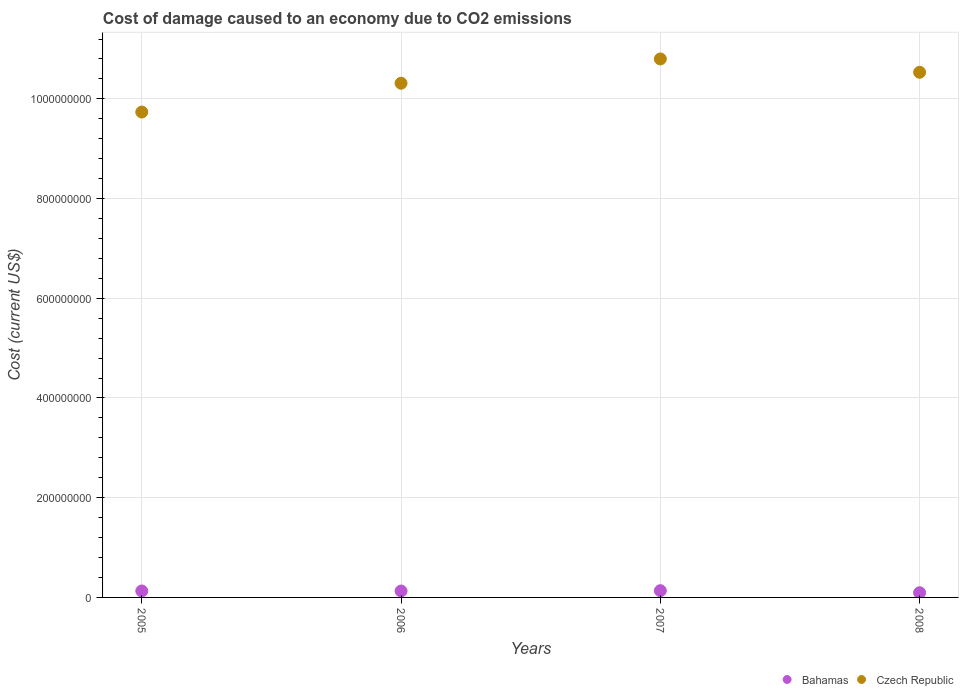How many different coloured dotlines are there?
Make the answer very short. 2. Is the number of dotlines equal to the number of legend labels?
Provide a short and direct response. Yes. What is the cost of damage caused due to CO2 emissisons in Bahamas in 2008?
Your answer should be very brief. 9.43e+06. Across all years, what is the maximum cost of damage caused due to CO2 emissisons in Czech Republic?
Keep it short and to the point. 1.08e+09. Across all years, what is the minimum cost of damage caused due to CO2 emissisons in Czech Republic?
Your answer should be very brief. 9.74e+08. In which year was the cost of damage caused due to CO2 emissisons in Bahamas minimum?
Your answer should be compact. 2008. What is the total cost of damage caused due to CO2 emissisons in Czech Republic in the graph?
Provide a short and direct response. 4.14e+09. What is the difference between the cost of damage caused due to CO2 emissisons in Bahamas in 2005 and that in 2006?
Your answer should be very brief. 1.12e+05. What is the difference between the cost of damage caused due to CO2 emissisons in Bahamas in 2006 and the cost of damage caused due to CO2 emissisons in Czech Republic in 2007?
Offer a terse response. -1.07e+09. What is the average cost of damage caused due to CO2 emissisons in Czech Republic per year?
Make the answer very short. 1.03e+09. In the year 2007, what is the difference between the cost of damage caused due to CO2 emissisons in Czech Republic and cost of damage caused due to CO2 emissisons in Bahamas?
Keep it short and to the point. 1.07e+09. In how many years, is the cost of damage caused due to CO2 emissisons in Bahamas greater than 360000000 US$?
Your answer should be compact. 0. What is the ratio of the cost of damage caused due to CO2 emissisons in Bahamas in 2006 to that in 2008?
Offer a very short reply. 1.36. What is the difference between the highest and the second highest cost of damage caused due to CO2 emissisons in Bahamas?
Keep it short and to the point. 5.94e+05. What is the difference between the highest and the lowest cost of damage caused due to CO2 emissisons in Bahamas?
Offer a very short reply. 4.12e+06. In how many years, is the cost of damage caused due to CO2 emissisons in Bahamas greater than the average cost of damage caused due to CO2 emissisons in Bahamas taken over all years?
Your response must be concise. 3. Does the cost of damage caused due to CO2 emissisons in Czech Republic monotonically increase over the years?
Ensure brevity in your answer.  No. Is the cost of damage caused due to CO2 emissisons in Bahamas strictly greater than the cost of damage caused due to CO2 emissisons in Czech Republic over the years?
Provide a succinct answer. No. How many dotlines are there?
Give a very brief answer. 2. How many years are there in the graph?
Your response must be concise. 4. Does the graph contain any zero values?
Offer a terse response. No. Does the graph contain grids?
Make the answer very short. Yes. How are the legend labels stacked?
Give a very brief answer. Horizontal. What is the title of the graph?
Your answer should be very brief. Cost of damage caused to an economy due to CO2 emissions. Does "Philippines" appear as one of the legend labels in the graph?
Offer a very short reply. No. What is the label or title of the Y-axis?
Your answer should be compact. Cost (current US$). What is the Cost (current US$) of Bahamas in 2005?
Make the answer very short. 1.30e+07. What is the Cost (current US$) of Czech Republic in 2005?
Provide a succinct answer. 9.74e+08. What is the Cost (current US$) in Bahamas in 2006?
Ensure brevity in your answer.  1.28e+07. What is the Cost (current US$) of Czech Republic in 2006?
Offer a very short reply. 1.03e+09. What is the Cost (current US$) of Bahamas in 2007?
Keep it short and to the point. 1.36e+07. What is the Cost (current US$) of Czech Republic in 2007?
Give a very brief answer. 1.08e+09. What is the Cost (current US$) in Bahamas in 2008?
Your response must be concise. 9.43e+06. What is the Cost (current US$) in Czech Republic in 2008?
Offer a very short reply. 1.05e+09. Across all years, what is the maximum Cost (current US$) in Bahamas?
Offer a terse response. 1.36e+07. Across all years, what is the maximum Cost (current US$) in Czech Republic?
Ensure brevity in your answer.  1.08e+09. Across all years, what is the minimum Cost (current US$) of Bahamas?
Your answer should be very brief. 9.43e+06. Across all years, what is the minimum Cost (current US$) in Czech Republic?
Offer a very short reply. 9.74e+08. What is the total Cost (current US$) of Bahamas in the graph?
Keep it short and to the point. 4.88e+07. What is the total Cost (current US$) of Czech Republic in the graph?
Offer a very short reply. 4.14e+09. What is the difference between the Cost (current US$) of Bahamas in 2005 and that in 2006?
Ensure brevity in your answer.  1.12e+05. What is the difference between the Cost (current US$) in Czech Republic in 2005 and that in 2006?
Provide a short and direct response. -5.78e+07. What is the difference between the Cost (current US$) in Bahamas in 2005 and that in 2007?
Keep it short and to the point. -5.94e+05. What is the difference between the Cost (current US$) of Czech Republic in 2005 and that in 2007?
Your answer should be very brief. -1.07e+08. What is the difference between the Cost (current US$) in Bahamas in 2005 and that in 2008?
Your answer should be very brief. 3.53e+06. What is the difference between the Cost (current US$) in Czech Republic in 2005 and that in 2008?
Your answer should be very brief. -7.98e+07. What is the difference between the Cost (current US$) in Bahamas in 2006 and that in 2007?
Provide a succinct answer. -7.05e+05. What is the difference between the Cost (current US$) of Czech Republic in 2006 and that in 2007?
Keep it short and to the point. -4.87e+07. What is the difference between the Cost (current US$) of Bahamas in 2006 and that in 2008?
Make the answer very short. 3.42e+06. What is the difference between the Cost (current US$) in Czech Republic in 2006 and that in 2008?
Provide a short and direct response. -2.20e+07. What is the difference between the Cost (current US$) in Bahamas in 2007 and that in 2008?
Offer a very short reply. 4.12e+06. What is the difference between the Cost (current US$) in Czech Republic in 2007 and that in 2008?
Keep it short and to the point. 2.68e+07. What is the difference between the Cost (current US$) in Bahamas in 2005 and the Cost (current US$) in Czech Republic in 2006?
Ensure brevity in your answer.  -1.02e+09. What is the difference between the Cost (current US$) in Bahamas in 2005 and the Cost (current US$) in Czech Republic in 2007?
Keep it short and to the point. -1.07e+09. What is the difference between the Cost (current US$) in Bahamas in 2005 and the Cost (current US$) in Czech Republic in 2008?
Keep it short and to the point. -1.04e+09. What is the difference between the Cost (current US$) of Bahamas in 2006 and the Cost (current US$) of Czech Republic in 2007?
Keep it short and to the point. -1.07e+09. What is the difference between the Cost (current US$) of Bahamas in 2006 and the Cost (current US$) of Czech Republic in 2008?
Provide a succinct answer. -1.04e+09. What is the difference between the Cost (current US$) in Bahamas in 2007 and the Cost (current US$) in Czech Republic in 2008?
Make the answer very short. -1.04e+09. What is the average Cost (current US$) of Bahamas per year?
Give a very brief answer. 1.22e+07. What is the average Cost (current US$) of Czech Republic per year?
Keep it short and to the point. 1.03e+09. In the year 2005, what is the difference between the Cost (current US$) in Bahamas and Cost (current US$) in Czech Republic?
Give a very brief answer. -9.61e+08. In the year 2006, what is the difference between the Cost (current US$) in Bahamas and Cost (current US$) in Czech Republic?
Your answer should be very brief. -1.02e+09. In the year 2007, what is the difference between the Cost (current US$) of Bahamas and Cost (current US$) of Czech Republic?
Provide a succinct answer. -1.07e+09. In the year 2008, what is the difference between the Cost (current US$) of Bahamas and Cost (current US$) of Czech Republic?
Your answer should be compact. -1.04e+09. What is the ratio of the Cost (current US$) of Bahamas in 2005 to that in 2006?
Make the answer very short. 1.01. What is the ratio of the Cost (current US$) of Czech Republic in 2005 to that in 2006?
Your answer should be very brief. 0.94. What is the ratio of the Cost (current US$) in Bahamas in 2005 to that in 2007?
Your answer should be very brief. 0.96. What is the ratio of the Cost (current US$) of Czech Republic in 2005 to that in 2007?
Provide a short and direct response. 0.9. What is the ratio of the Cost (current US$) in Bahamas in 2005 to that in 2008?
Offer a very short reply. 1.37. What is the ratio of the Cost (current US$) in Czech Republic in 2005 to that in 2008?
Your answer should be compact. 0.92. What is the ratio of the Cost (current US$) in Bahamas in 2006 to that in 2007?
Offer a very short reply. 0.95. What is the ratio of the Cost (current US$) in Czech Republic in 2006 to that in 2007?
Make the answer very short. 0.95. What is the ratio of the Cost (current US$) of Bahamas in 2006 to that in 2008?
Your answer should be very brief. 1.36. What is the ratio of the Cost (current US$) of Czech Republic in 2006 to that in 2008?
Offer a very short reply. 0.98. What is the ratio of the Cost (current US$) of Bahamas in 2007 to that in 2008?
Offer a terse response. 1.44. What is the ratio of the Cost (current US$) of Czech Republic in 2007 to that in 2008?
Offer a terse response. 1.03. What is the difference between the highest and the second highest Cost (current US$) of Bahamas?
Give a very brief answer. 5.94e+05. What is the difference between the highest and the second highest Cost (current US$) in Czech Republic?
Your response must be concise. 2.68e+07. What is the difference between the highest and the lowest Cost (current US$) in Bahamas?
Provide a succinct answer. 4.12e+06. What is the difference between the highest and the lowest Cost (current US$) of Czech Republic?
Ensure brevity in your answer.  1.07e+08. 